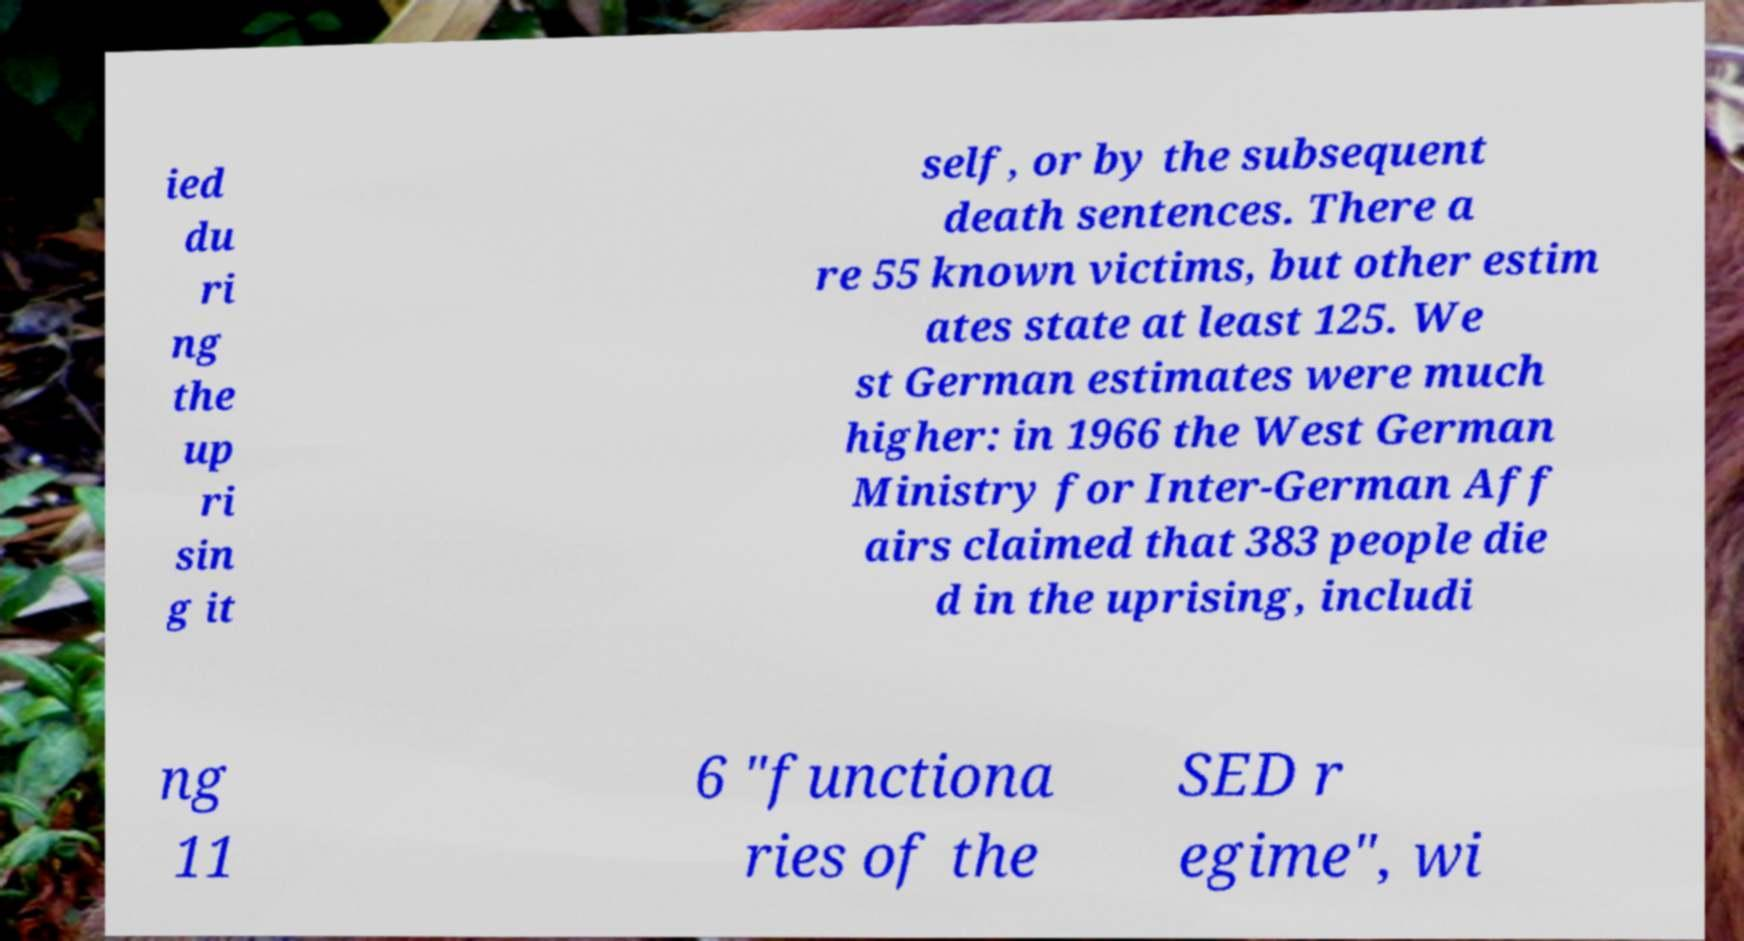Could you assist in decoding the text presented in this image and type it out clearly? ied du ri ng the up ri sin g it self, or by the subsequent death sentences. There a re 55 known victims, but other estim ates state at least 125. We st German estimates were much higher: in 1966 the West German Ministry for Inter-German Aff airs claimed that 383 people die d in the uprising, includi ng 11 6 "functiona ries of the SED r egime", wi 